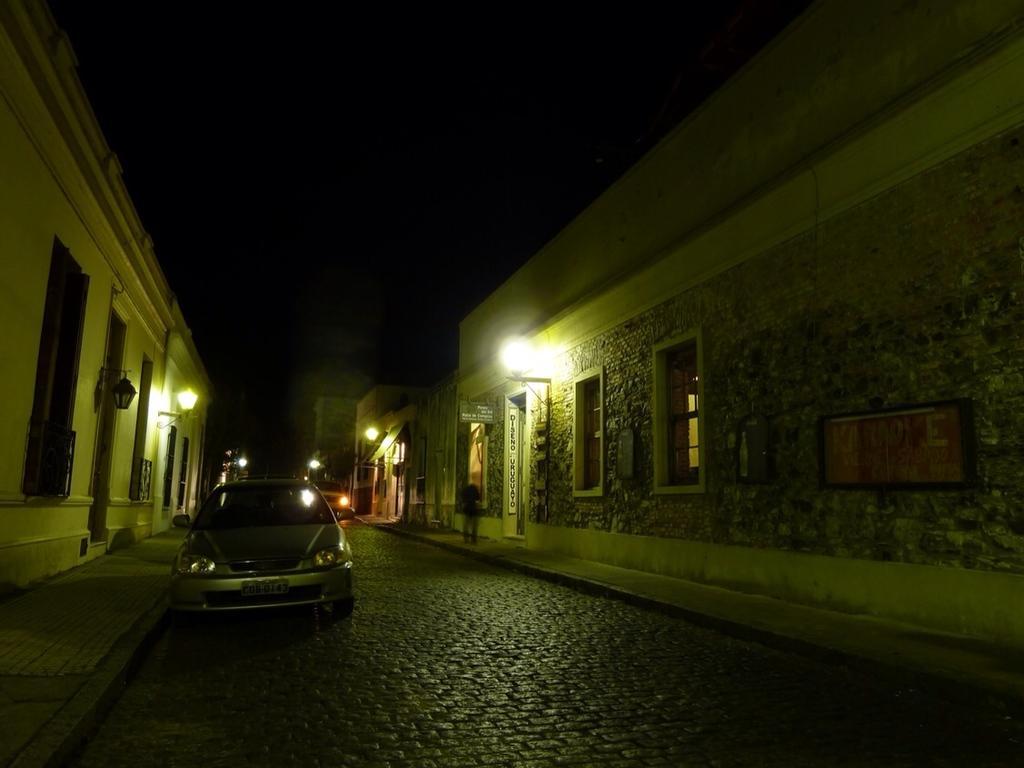Could you give a brief overview of what you see in this image? In this image in the center there is a car on the road. On the left side there are buildings and there are lights hanging. In the background there are lights. On the right side there are buildings and there is a person standing and there are lights hanging and there are windows. 